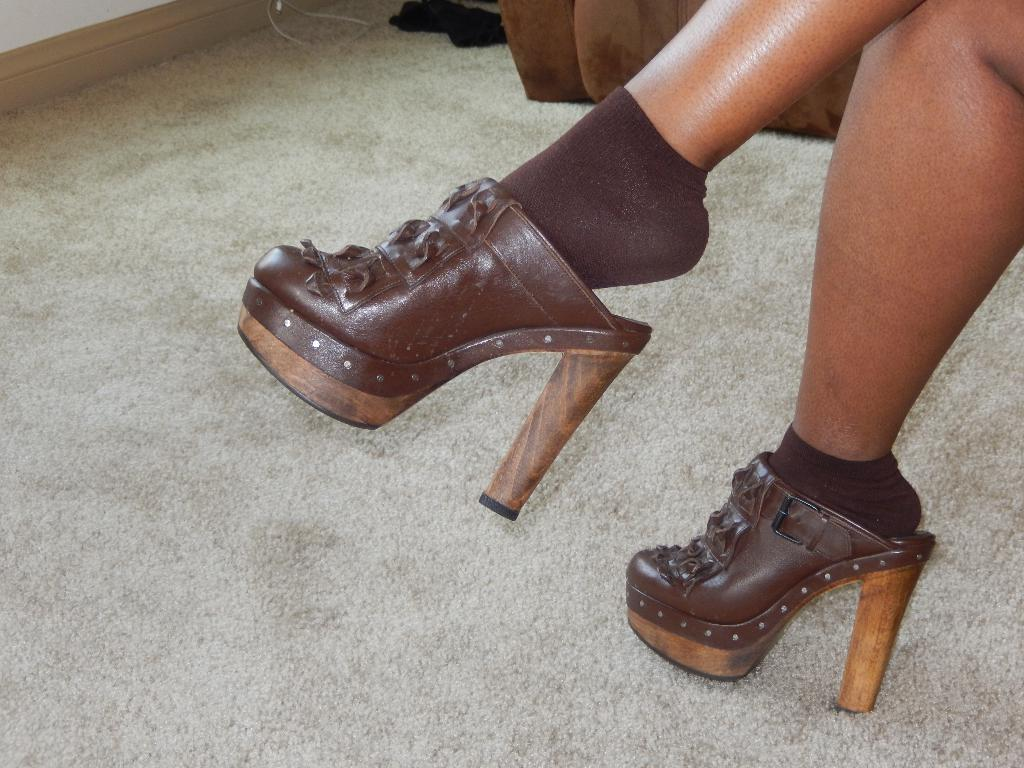What body part is visible in the image? There are legs of a human in the image. What type of clothing is the person wearing on their feet? The person is wearing brown socks and brown-colored footwear. What can be seen on the floor in the image? There is a floor carpet in the image. What type of object can be seen in the image that is typically used for transmitting electricity? There is a wire in the image. What color is the cloth present in the image? The cloth in the image is black. What type of letter is being written on the cherry in the image? There is no letter or cherry present in the image. What is the person's income based on the image? The image does not provide any information about the person's income. 